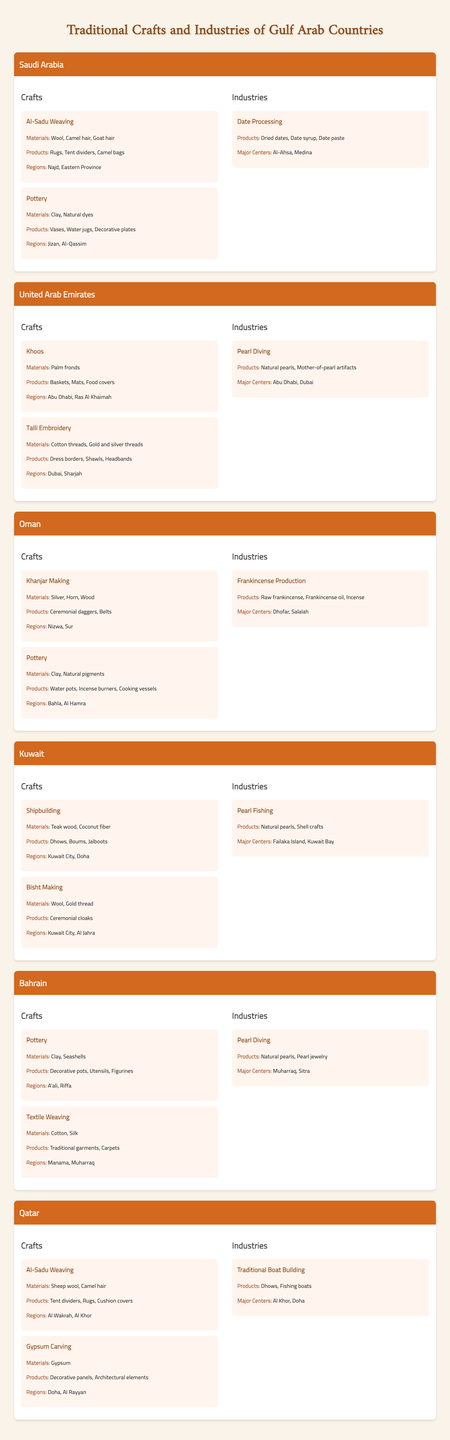What traditional craft is prominent in Saudi Arabia that involves weaving with sheep wool and camel hair? The table lists traditional crafts in Saudi Arabia, and it mentions "Al-Sadu Weaving" specifically, which uses sheep wool and camel hair as materials.
Answer: Al-Sadu Weaving Which Gulf country is known for its pearling industry? The table indicates that both Kuwait and Bahrain have industries related to pearl diving, thus highlighting their historical significance in this craft.
Answer: Kuwait and Bahrain What materials are used in the Talli embroidery craft in the UAE? According to the table, Talli embroidery in the UAE uses "cotton threads" as well as "gold and silver threads."
Answer: Cotton threads, gold and silver threads Which country has a craft specifically for making ceremonial daggers? The table shows that Oman has a craft called "Khanjar Making," which is focused on creating ceremonial daggers.
Answer: Oman How many regions are mentioned for pottery crafts in Saudi Arabia? The table lists two regions for pottery in Saudi Arabia, which are Jizan and Al-Qassim. Therefore, there are two regions mentioned for this craft.
Answer: 2 What are the major centers for date processing in Saudi Arabia? The data indicates that the major centers for date processing in Saudi Arabia are Al-Ahsa and Medina, as listed under the date processing industry.
Answer: Al-Ahsa, Medina Is pottery also crafted in Oman? Yes, the table confirms that Oman has pottery listed as one of its traditional crafts, indicating it is indeed made there.
Answer: Yes Compare the traditional crafts of Qatar and Kuwait. Which country uses gypsum as a primary material in one of its crafts? The table shows that Qatar engages in "Gypsum Carving," thus utilizing gypsum as a material, while Kuwait focuses on shipbuilding and bisht making. Therefore, Qatar is the country using gypsum.
Answer: Qatar What products are associated with the Al-Sadu Weaving in Qatar? Al-Sadu Weaving in Qatar is associated with producing "Tent dividers," "Rugs," and "Cushion covers," as listed in the table.
Answer: Tent dividers, rugs, cushion covers Count the number of traditional crafts listed for Bahrain. The table shows there are two traditional crafts mentioned for Bahrain, which are pottery and textile weaving. Thus, the total count is 2.
Answer: 2 